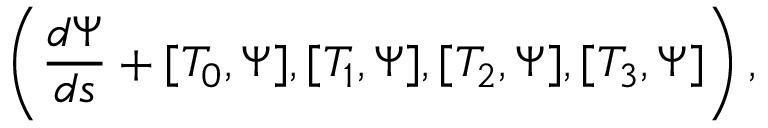<formula> <loc_0><loc_0><loc_500><loc_500>\left ( \frac { d \Psi } { d s } + [ { T } _ { 0 } , \Psi ] , [ { T } _ { 1 } , \Psi ] , [ { T } _ { 2 } , \Psi ] , [ { T } _ { 3 } , \Psi ] \right ) ,</formula> 